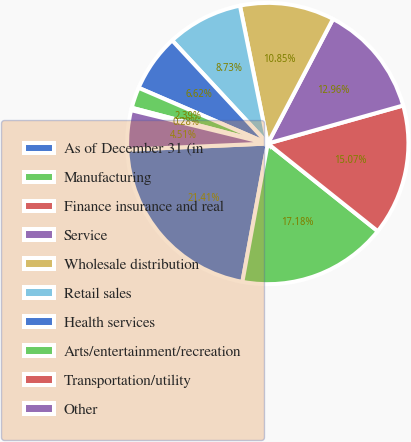Convert chart. <chart><loc_0><loc_0><loc_500><loc_500><pie_chart><fcel>As of December 31 (in<fcel>Manufacturing<fcel>Finance insurance and real<fcel>Service<fcel>Wholesale distribution<fcel>Retail sales<fcel>Health services<fcel>Arts/entertainment/recreation<fcel>Transportation/utility<fcel>Other<nl><fcel>21.41%<fcel>17.18%<fcel>15.07%<fcel>12.96%<fcel>10.85%<fcel>8.73%<fcel>6.62%<fcel>2.39%<fcel>0.28%<fcel>4.51%<nl></chart> 